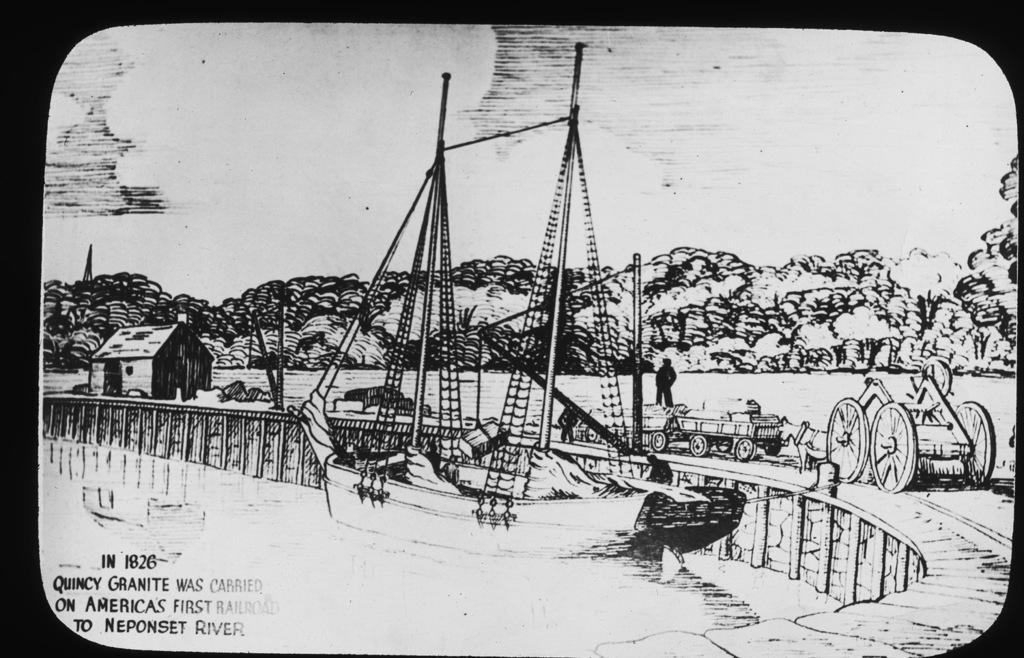What is present in the image that contains images and text? There is a poster in the image that contains images and text. Can you describe the images on the poster? The provided facts do not give specific details about the images on the poster, so we cannot describe them. What type of text is written on the poster? The provided facts do not give specific details about the text on the poster, so we cannot describe it. How many sticks are being held by the minister in the image? There is no minister or sticks present in the image. 